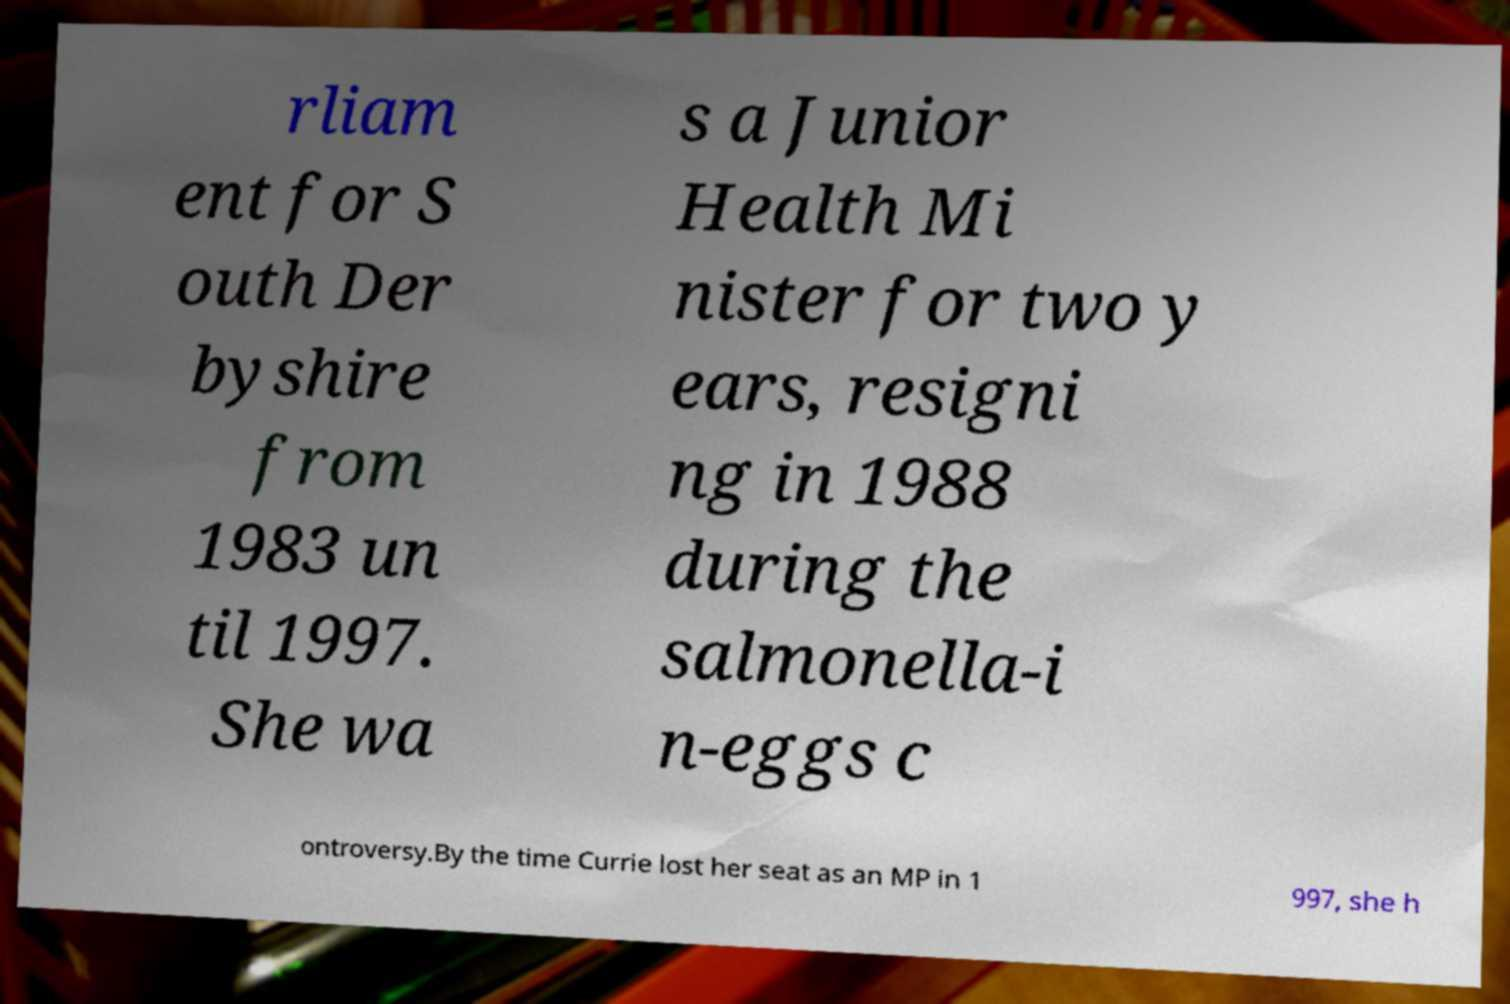Please read and relay the text visible in this image. What does it say? rliam ent for S outh Der byshire from 1983 un til 1997. She wa s a Junior Health Mi nister for two y ears, resigni ng in 1988 during the salmonella-i n-eggs c ontroversy.By the time Currie lost her seat as an MP in 1 997, she h 